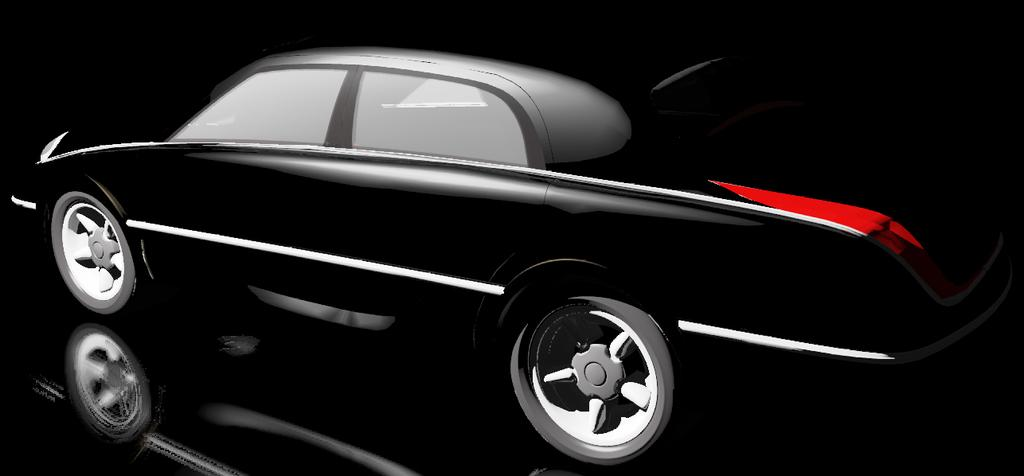What is the main subject of the picture? The main subject of the picture is a car. Can you describe the car in the image? The car is black. What can be seen in the background of the image? The background of the image is dark. Is there any additional detail visible in the image? Yes, there is a reflection of the car visible at the bottom of the image. What joke is the father telling in the image? There is no father or joke present in the image; it features a black car with a reflection. 